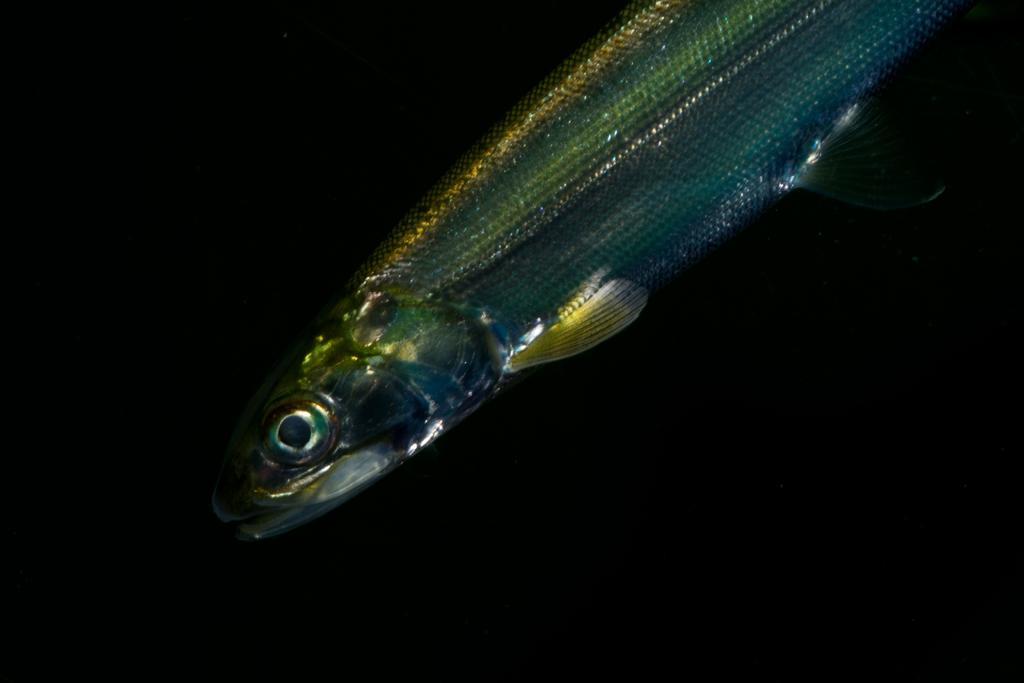How would you summarize this image in a sentence or two? In the center of the image we can see a fish. And we can see the black colored background. 